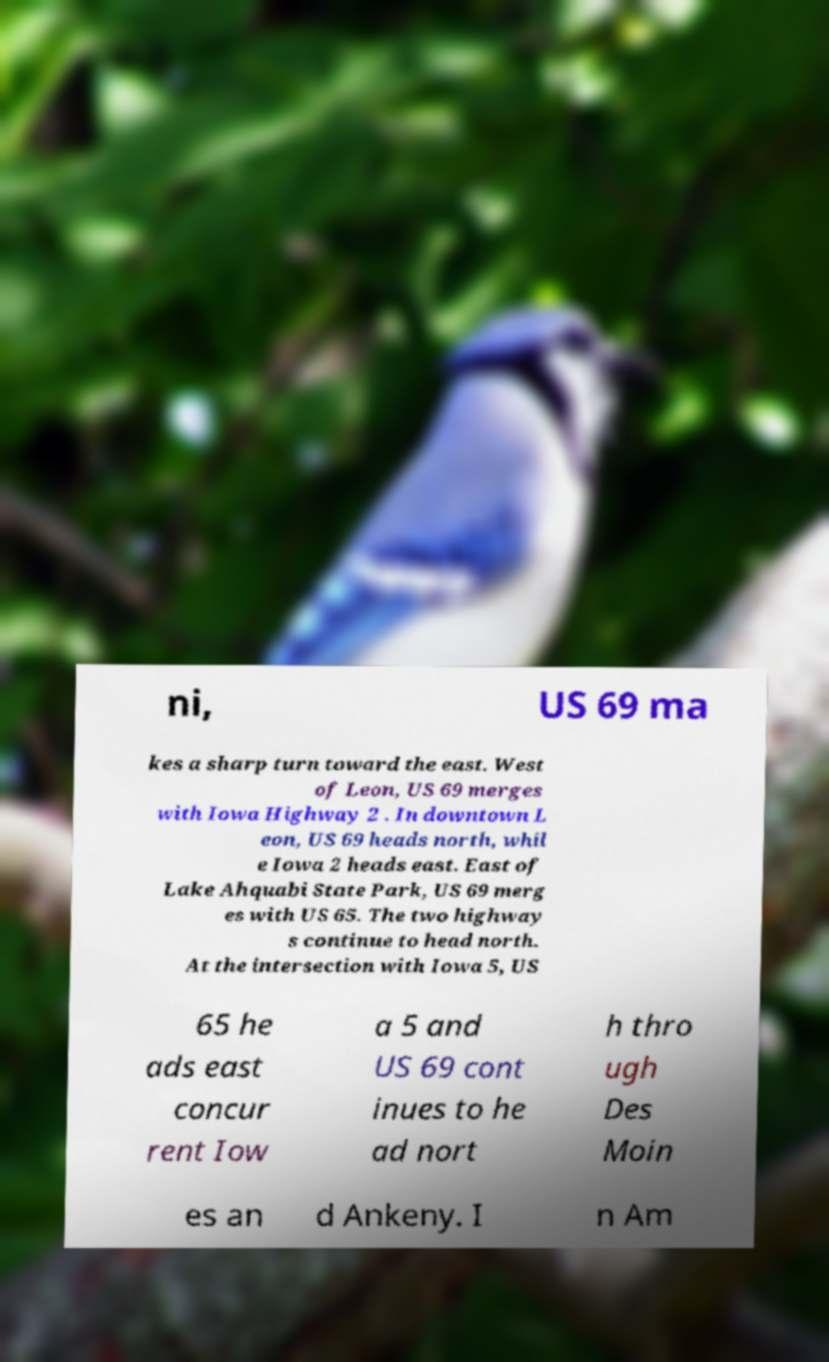Could you assist in decoding the text presented in this image and type it out clearly? ni, US 69 ma kes a sharp turn toward the east. West of Leon, US 69 merges with Iowa Highway 2 . In downtown L eon, US 69 heads north, whil e Iowa 2 heads east. East of Lake Ahquabi State Park, US 69 merg es with US 65. The two highway s continue to head north. At the intersection with Iowa 5, US 65 he ads east concur rent Iow a 5 and US 69 cont inues to he ad nort h thro ugh Des Moin es an d Ankeny. I n Am 